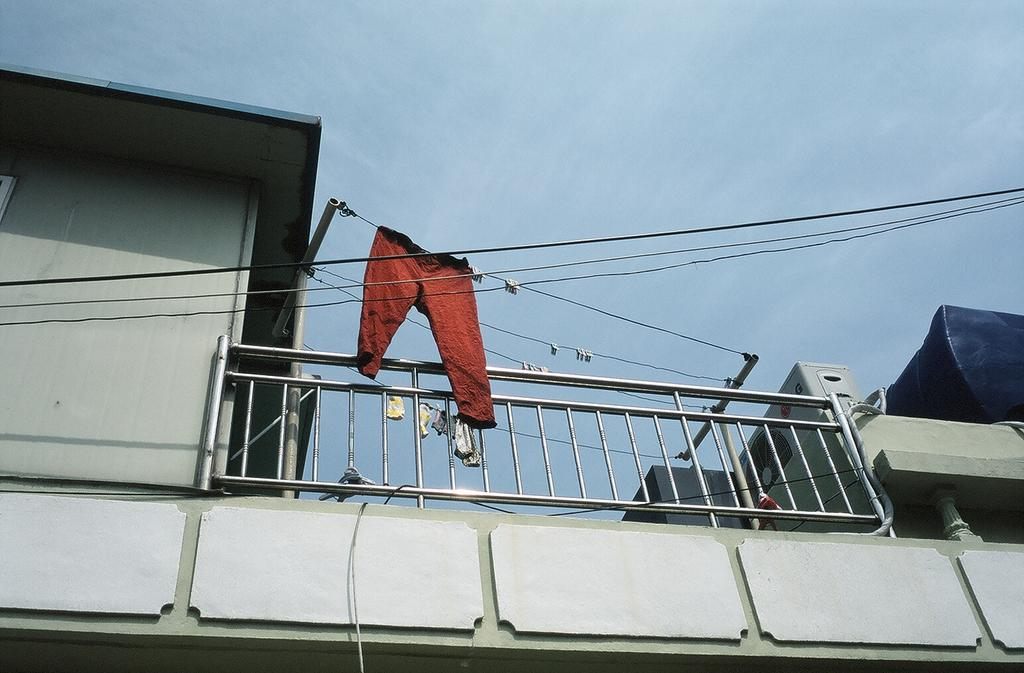What type of structure is present in the image? There is a building in the image. What can be seen on top of the building? There is railing on top of the building. What else is visible in the image besides the building? There are wires visible in the image. What might be hanging near the railing? There are clothes near the railing. What is visible in the background of the image? The sky is visible in the background of the image. How many brothers are depicted in the image? There are no brothers present in the image. What theory is being discussed in the image? There is no discussion or theory present in the image. 